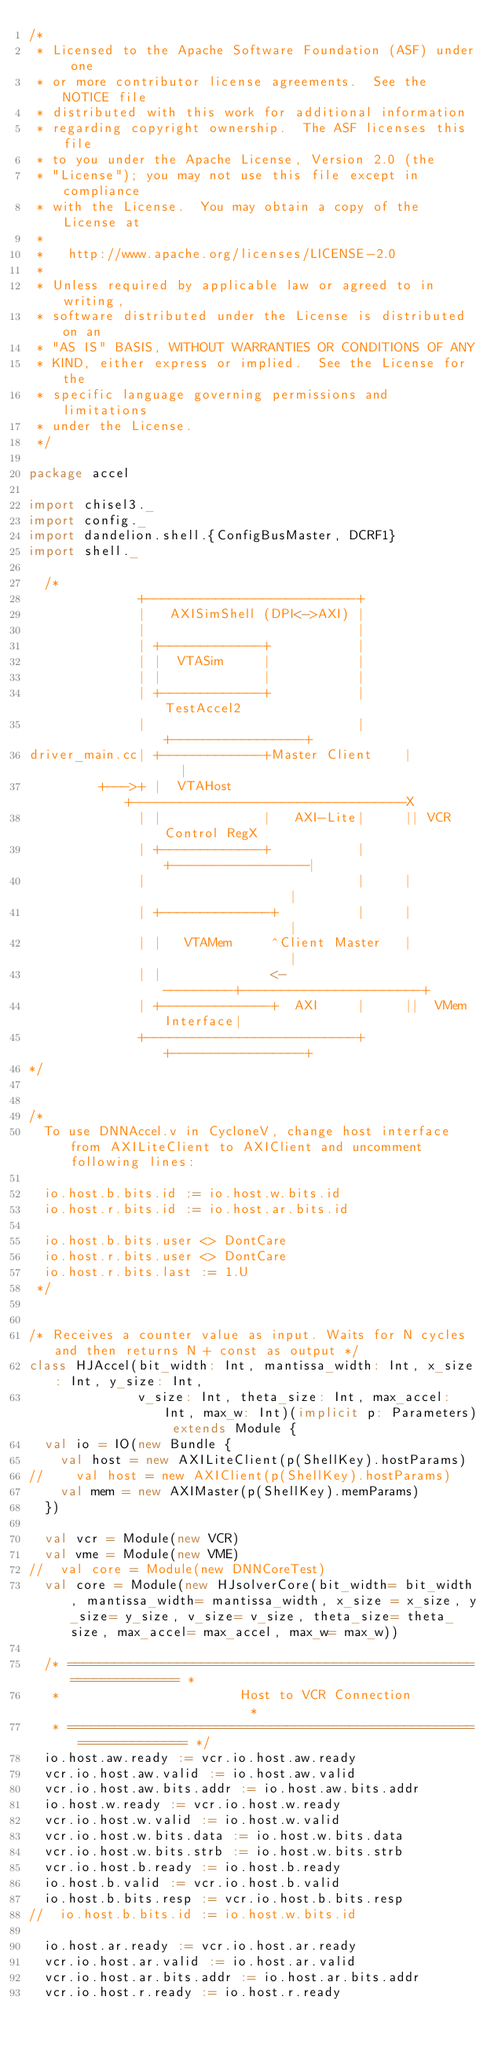Convert code to text. <code><loc_0><loc_0><loc_500><loc_500><_Scala_>/*
 * Licensed to the Apache Software Foundation (ASF) under one
 * or more contributor license agreements.  See the NOTICE file
 * distributed with this work for additional information
 * regarding copyright ownership.  The ASF licenses this file
 * to you under the Apache License, Version 2.0 (the
 * "License"); you may not use this file except in compliance
 * with the License.  You may obtain a copy of the License at
 *
 *   http://www.apache.org/licenses/LICENSE-2.0
 *
 * Unless required by applicable law or agreed to in writing,
 * software distributed under the License is distributed on an
 * "AS IS" BASIS, WITHOUT WARRANTIES OR CONDITIONS OF ANY
 * KIND, either express or implied.  See the License for the
 * specific language governing permissions and limitations
 * under the License.
 */

package accel

import chisel3._
import config._
import dandelion.shell.{ConfigBusMaster, DCRF1}
import shell._

  /*
              +---------------------------+
              |   AXISimShell (DPI<->AXI) |
              |                           |
              | +-------------+           |
              | |  VTASim     |           |
              | |             |           |
              | +-------------+           |        TestAccel2
              |                           |     +-----------------+
driver_main.cc| +-------------+Master Client    |                 |
         +--->+ |  VTAHost    +-----------------------------------X
              | |             |   AXI-Lite|     || VCR Control RegX
              | +-------------+           |     +-----------------|
              |                           |     |                 |
              | +--------------+          |     |                 |
              | |   VTAMem     ^Client Master   |                 |
              | |              <----------+-----------------------+
              | +--------------+  AXI     |     ||  VMem Interface|
              +---------------------------+     +-----------------+
*/


/*
  To use DNNAccel.v in CycloneV, change host interface from AXILiteClient to AXIClient and uncomment following lines:

  io.host.b.bits.id := io.host.w.bits.id
  io.host.r.bits.id := io.host.ar.bits.id

  io.host.b.bits.user <> DontCare
  io.host.r.bits.user <> DontCare
  io.host.r.bits.last := 1.U
 */


/* Receives a counter value as input. Waits for N cycles and then returns N + const as output */
class HJAccel(bit_width: Int, mantissa_width: Int, x_size: Int, y_size: Int,
              v_size: Int, theta_size: Int, max_accel: Int, max_w: Int)(implicit p: Parameters) extends Module {
  val io = IO(new Bundle {
    val host = new AXILiteClient(p(ShellKey).hostParams)
//    val host = new AXIClient(p(ShellKey).hostParams)
    val mem = new AXIMaster(p(ShellKey).memParams)
  })

  val vcr = Module(new VCR)
  val vme = Module(new VME)
//  val core = Module(new DNNCoreTest)
  val core = Module(new HJsolverCore(bit_width= bit_width, mantissa_width= mantissa_width, x_size = x_size, y_size= y_size, v_size= v_size, theta_size= theta_size, max_accel= max_accel, max_w= max_w))

  /* ================================================================== *
   *                       Host to VCR Connection                       *
   * ================================================================== */
  io.host.aw.ready := vcr.io.host.aw.ready
  vcr.io.host.aw.valid := io.host.aw.valid
  vcr.io.host.aw.bits.addr := io.host.aw.bits.addr
  io.host.w.ready := vcr.io.host.w.ready
  vcr.io.host.w.valid := io.host.w.valid
  vcr.io.host.w.bits.data := io.host.w.bits.data
  vcr.io.host.w.bits.strb := io.host.w.bits.strb
  vcr.io.host.b.ready := io.host.b.ready
  io.host.b.valid := vcr.io.host.b.valid
  io.host.b.bits.resp := vcr.io.host.b.bits.resp
//  io.host.b.bits.id := io.host.w.bits.id

  io.host.ar.ready := vcr.io.host.ar.ready
  vcr.io.host.ar.valid := io.host.ar.valid
  vcr.io.host.ar.bits.addr := io.host.ar.bits.addr
  vcr.io.host.r.ready := io.host.r.ready</code> 